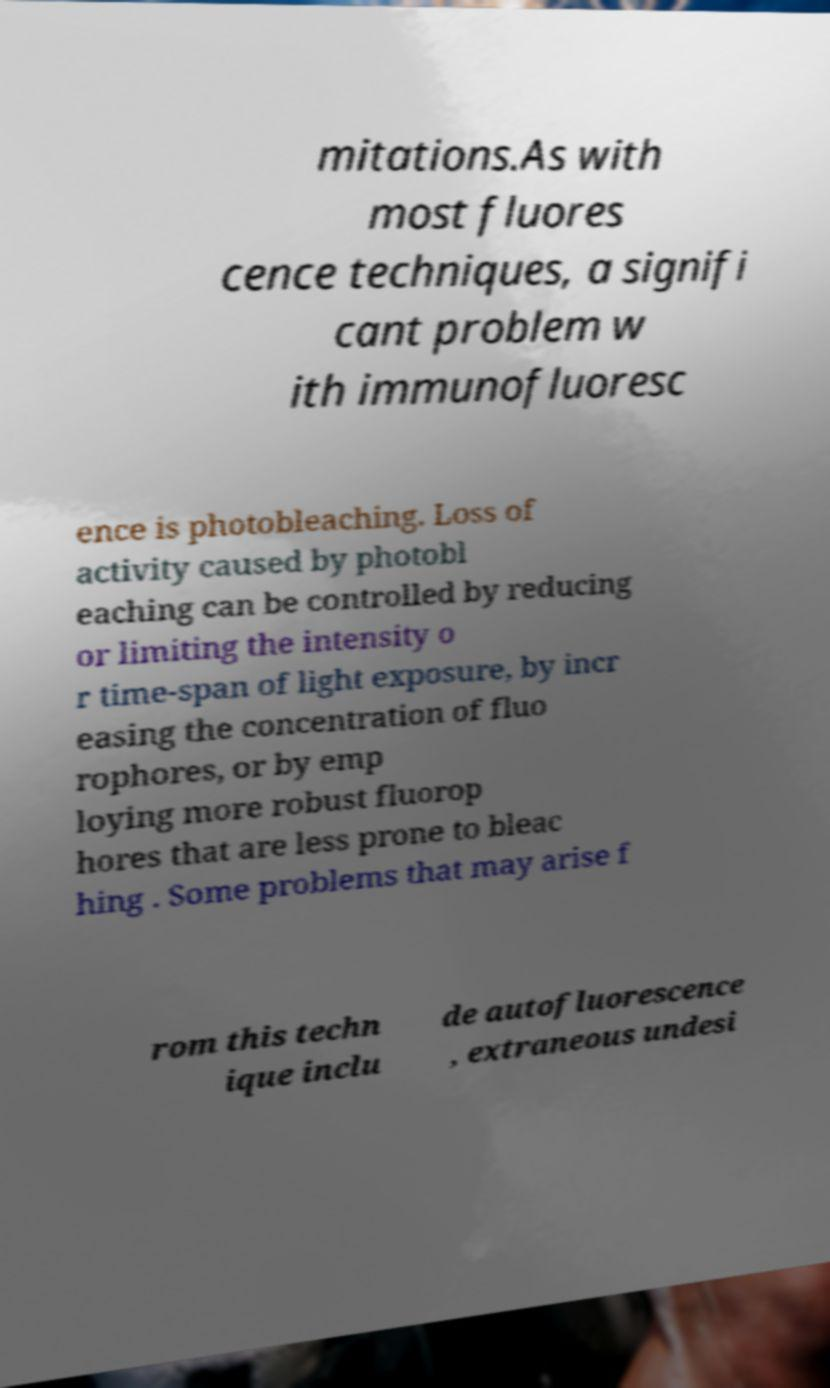There's text embedded in this image that I need extracted. Can you transcribe it verbatim? mitations.As with most fluores cence techniques, a signifi cant problem w ith immunofluoresc ence is photobleaching. Loss of activity caused by photobl eaching can be controlled by reducing or limiting the intensity o r time-span of light exposure, by incr easing the concentration of fluo rophores, or by emp loying more robust fluorop hores that are less prone to bleac hing . Some problems that may arise f rom this techn ique inclu de autofluorescence , extraneous undesi 